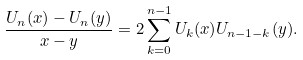<formula> <loc_0><loc_0><loc_500><loc_500>\frac { U _ { n } ( x ) - U _ { n } ( y ) } { x - y } = 2 \sum _ { k = 0 } ^ { n - 1 } U _ { k } ( x ) U _ { n - 1 - k } ( y ) .</formula> 